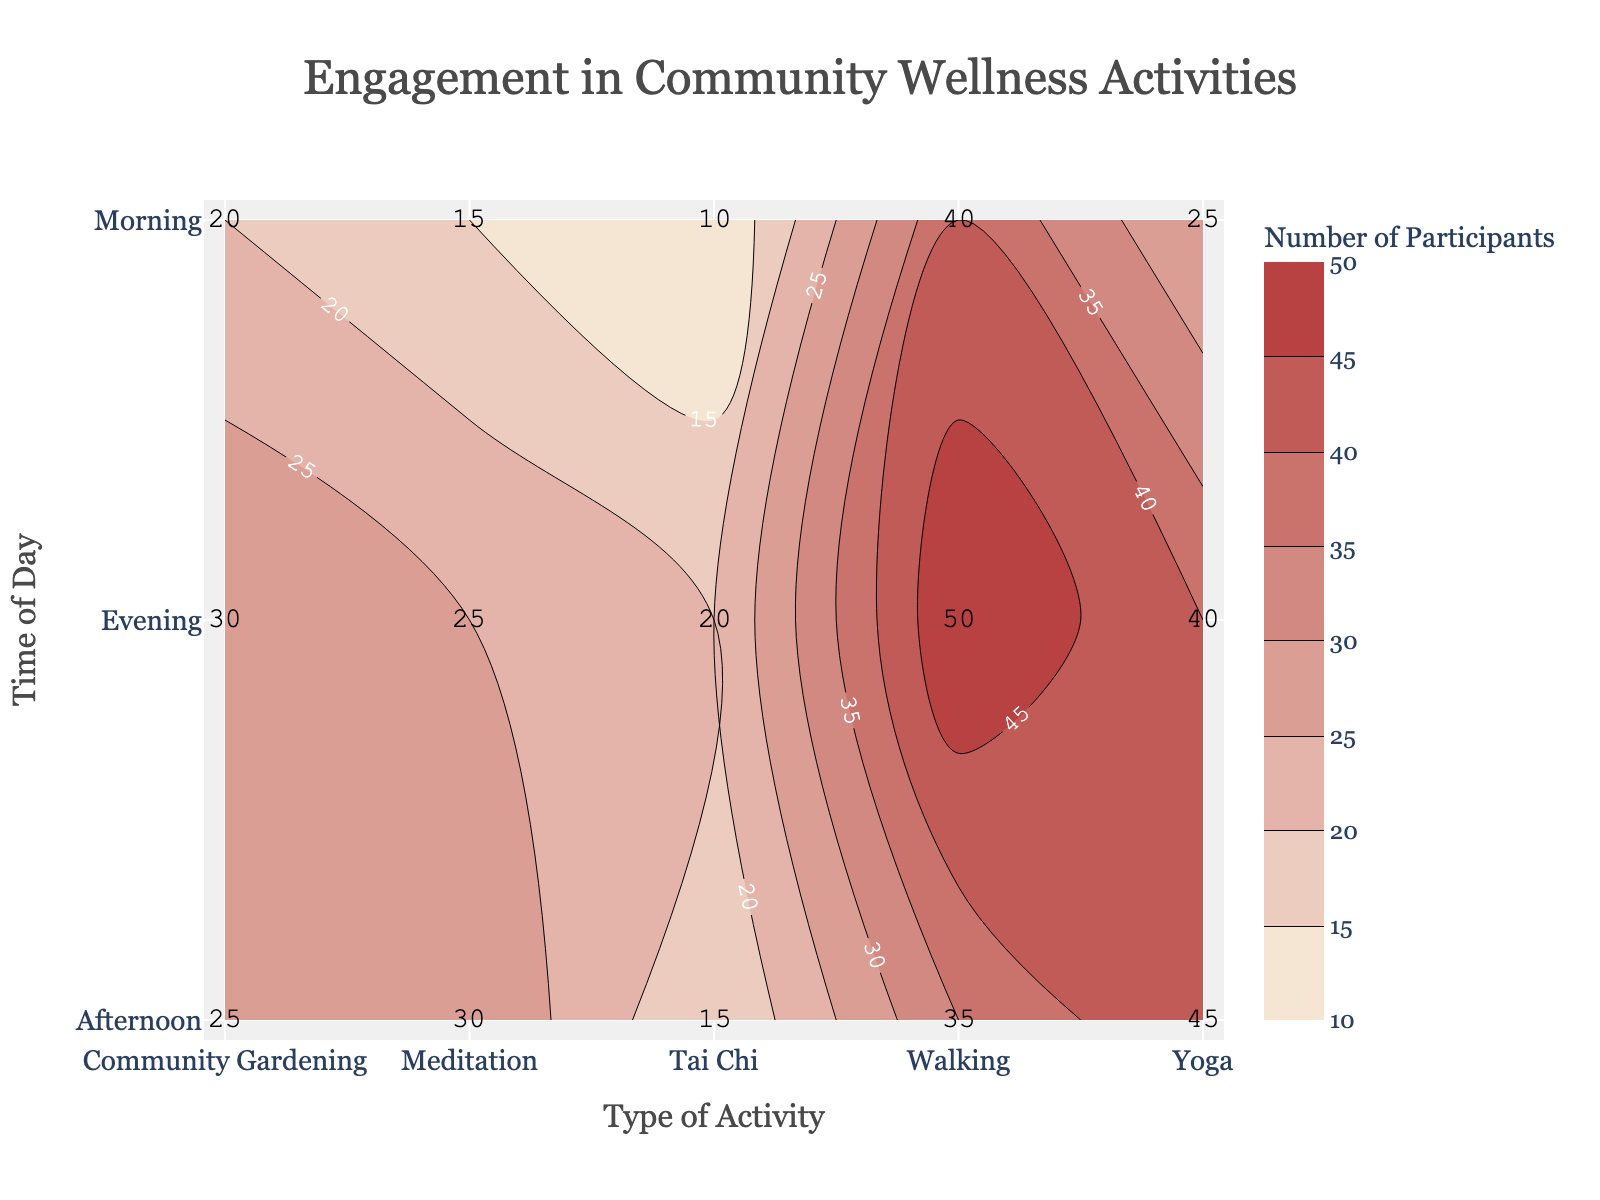What's the title of the plot? The title of the plot is located at the top center of the figure, and it describes what the visualization is about.
Answer: Engagement in Community Wellness Activities What color represents the highest number of participants? By comparing the colors in the contour plot to the color scale provided, the darkest color represents the highest number of participants.
Answer: Dark Red (or similar) What are the labels on the y-axis? The y-axis labels denote different times of day when the activities are conducted.
Answer: Morning, Afternoon, Evening Which activity has the lowest participation in the morning? By examining the annotations within the Morning row, the activity with the smallest number is identified.
Answer: Tai Chi What is the total number of participants for Yoga across all times of day? By summing up the participant numbers for Yoga in Morning, Afternoon, and Evening, we get the total. 25 + 45 + 40 = 110.
Answer: 110 Which time of day has the highest aggregate number of participants? Sum the participant numbers across all activities for each time of day and compare. Morning: 15+25+40+20+10=110, Afternoon: 30+45+35+25+15=150, Evening: 25+40+50+30+20=165. Evening has the highest total.
Answer: Evening How does participation in Meditation vary across different times of day? Compare the participant numbers for Meditation in the Morning, Afternoon, and Evening. Morning: 15, Afternoon: 30, Evening: 25. Participation increases from morning to afternoon, then slightly decreases in the evening.
Answer: Morning < Afternoon > Evening Is there any activity where the number of participants is constant across all times of day? Check each activity to see if the participant numbers remain the same for Morning, Afternoon, and Evening. There are no such activities with a constant number across all times.
Answer: No What is the average number of participants in the Community Gardening activity? Sum the participant numbers for Community Gardening and divide by the number of time slots. (20+25+30)/3 = 75/3 = 25
Answer: 25 